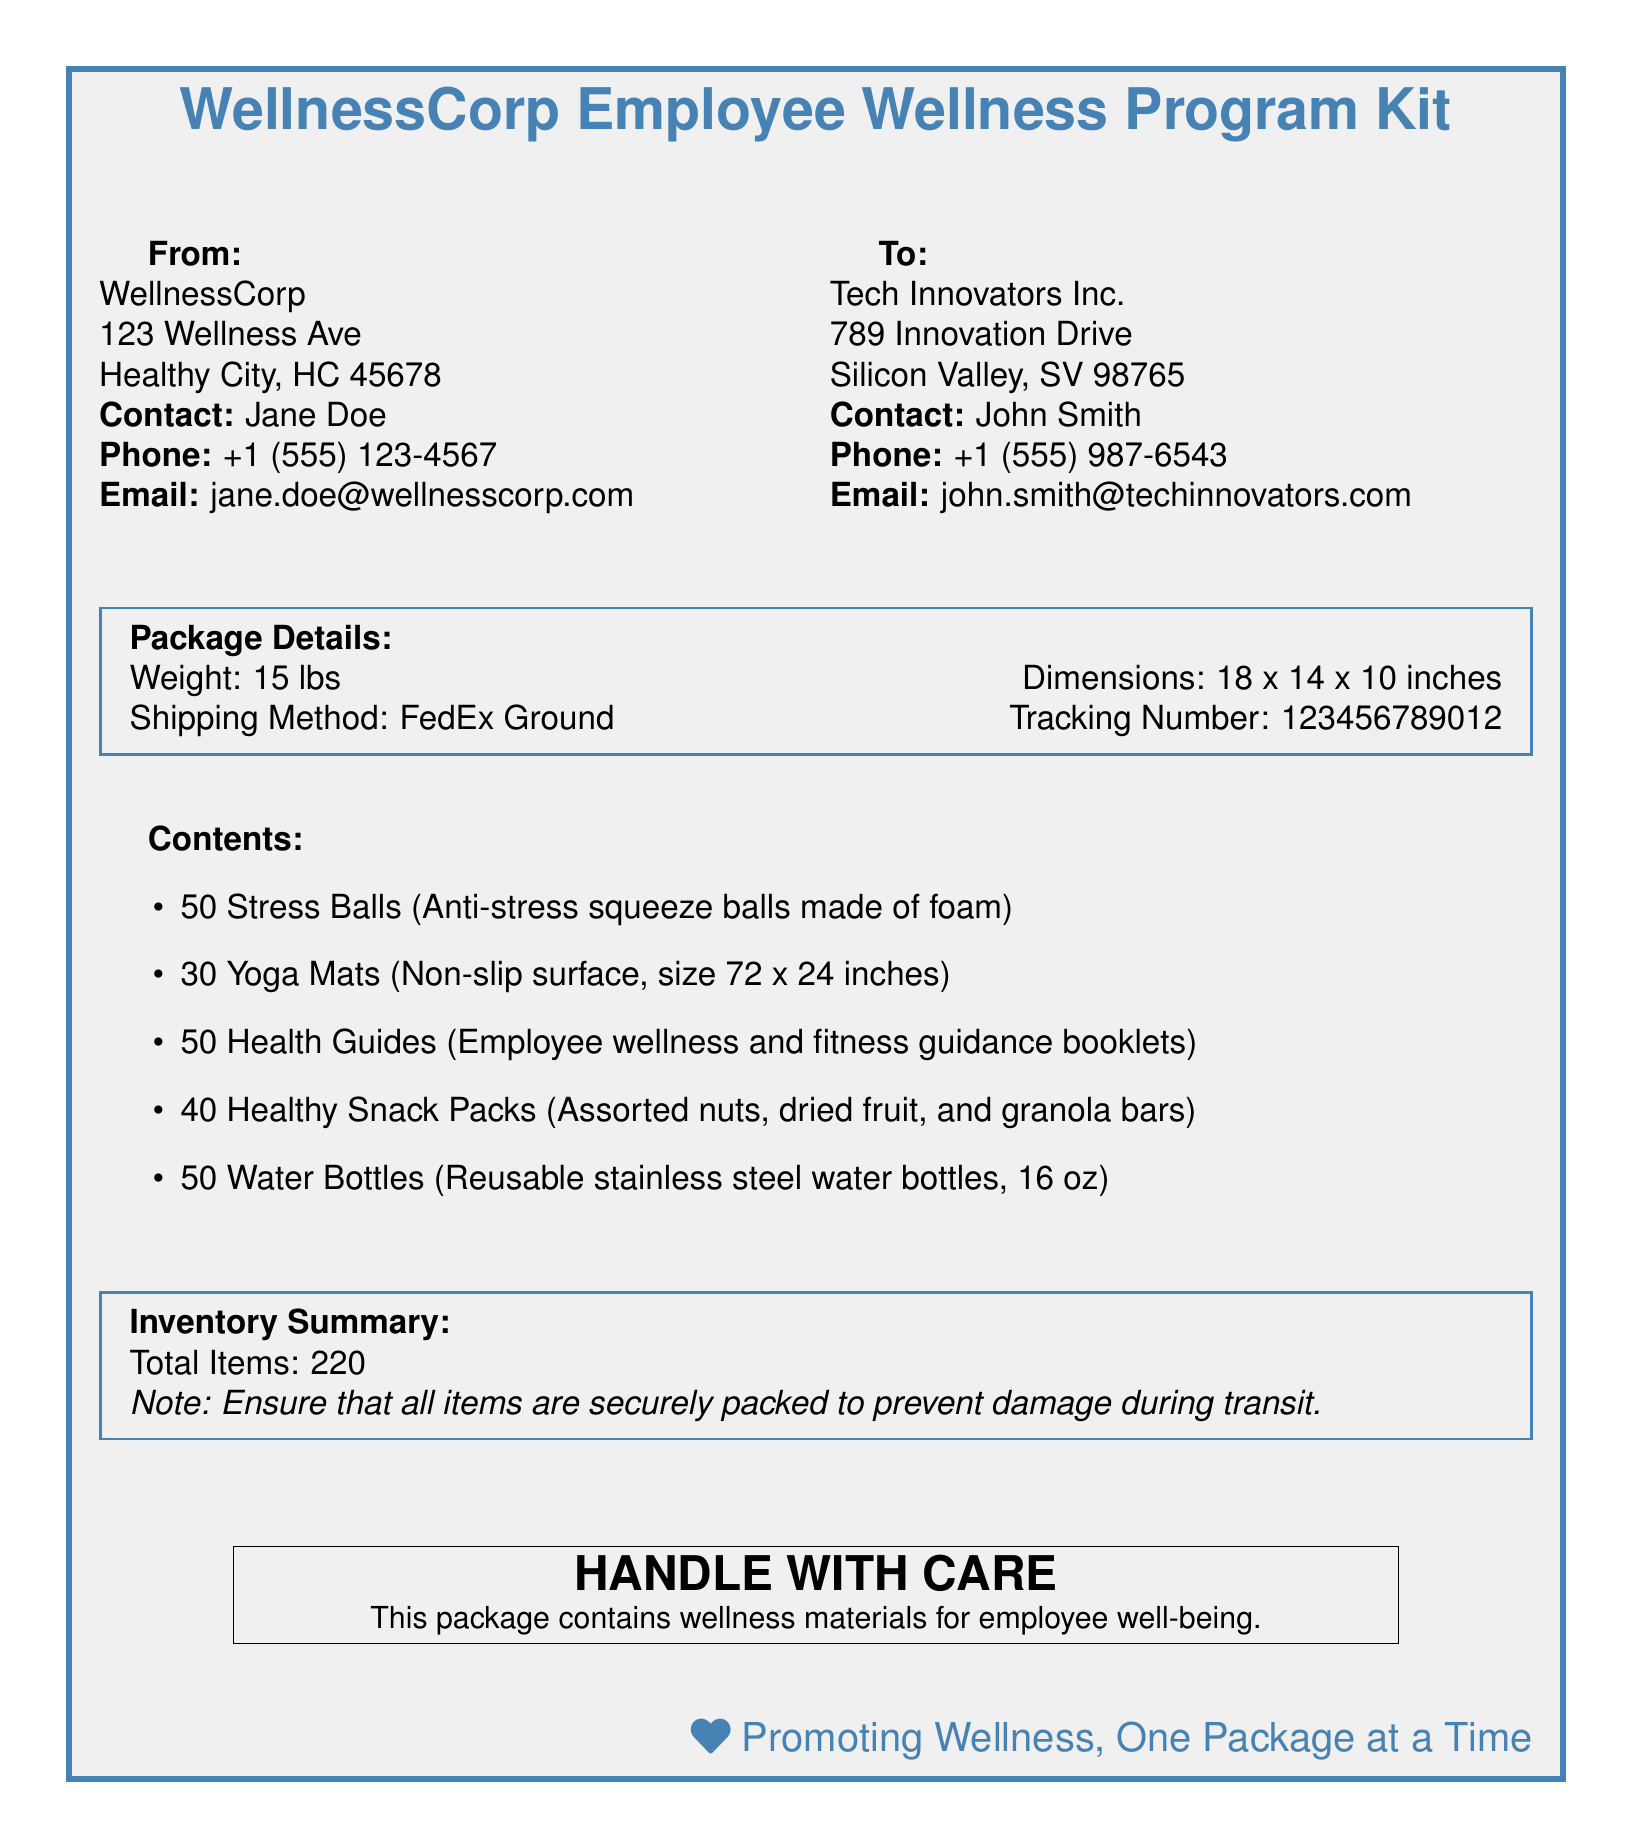what is the total weight of the package? The total weight of the package is explicitly listed in the package details section of the document.
Answer: 15 lbs who is the contact person for WellnessCorp? The contact person for WellnessCorp is clearly mentioned in the sender's section of the document.
Answer: Jane Doe what are the dimensions of the package? The dimensions of the package are provided in the package details section, which describes the size in inches.
Answer: 18 x 14 x 10 inches how many water bottles are included in the kit? The number of water bottles is stated in the contents list of the document, specifically mentioning the quantity.
Answer: 50 what is the purpose of the materials in the package? The purpose of the materials is indicated in the note on the package, explaining the general reason for the shipment.
Answer: employee well-being what shipping method is used for delivery? The shipping method is mentioned in the package details of the document.
Answer: FedEx Ground what is the total number of items included in the inventory summary? The total number of items can be found in the inventory summary section, clearly stated as the sum of all items.
Answer: 220 how many healthy snack packs were sent? The quantity of healthy snack packs is specified in the contents list of the document.
Answer: 40 what is the contact email for John Smith? The contact email for John Smith is found in the recipient's section of the document.
Answer: john.smith@techinnovators.com 